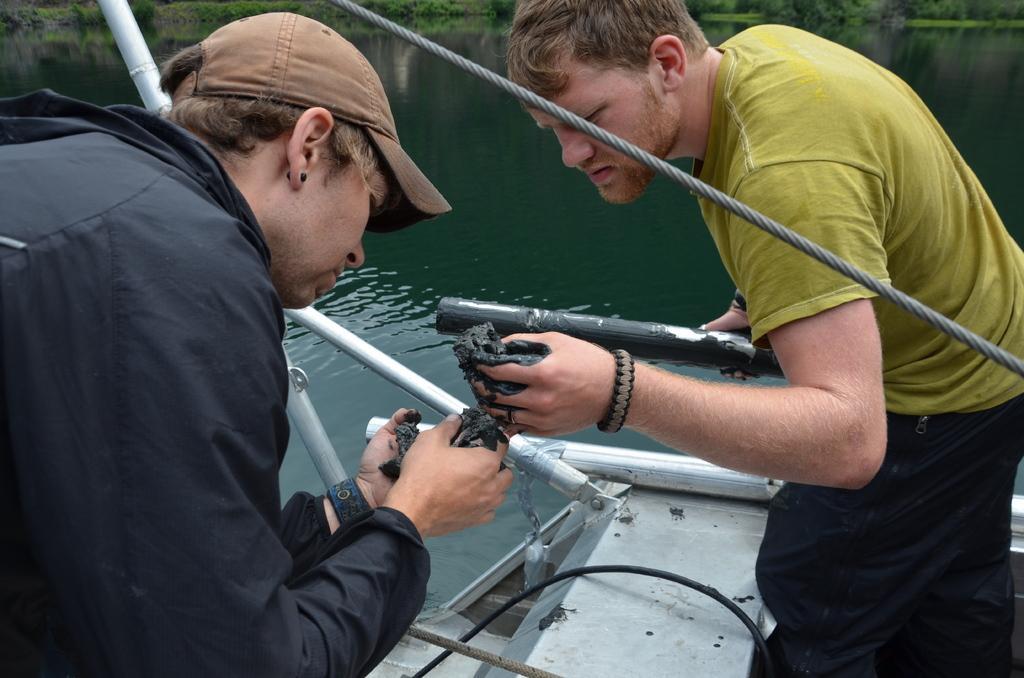Can you describe this image briefly? In this image I can see two people wearing the black and green color dresses and these people are standing on the boat. I can see one person with the black color jacket wearing the cap. The boat is on the water. In the background I can see many trees. 